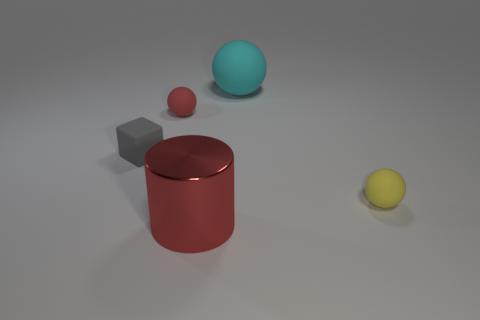Add 2 large purple matte blocks. How many objects exist? 7 Subtract all large cyan matte spheres. How many spheres are left? 2 Subtract all cyan balls. How many balls are left? 2 Subtract 1 cubes. How many cubes are left? 0 Subtract all blue blocks. How many yellow spheres are left? 1 Subtract all cylinders. Subtract all large brown rubber balls. How many objects are left? 4 Add 3 red objects. How many red objects are left? 5 Add 3 large gray matte blocks. How many large gray matte blocks exist? 3 Subtract 1 red cylinders. How many objects are left? 4 Subtract all cylinders. How many objects are left? 4 